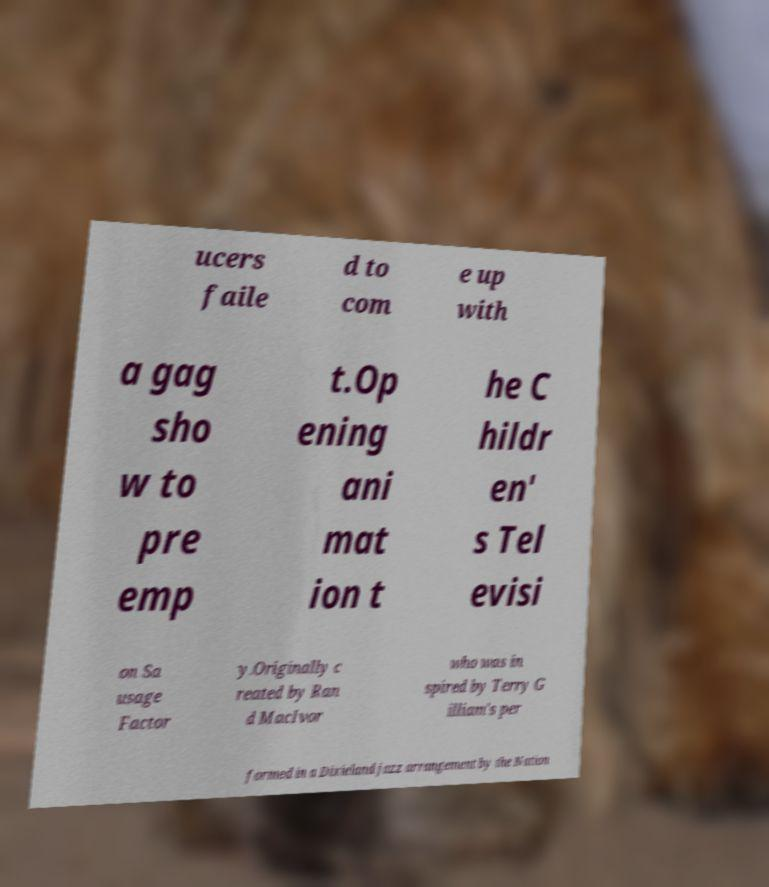Can you read and provide the text displayed in the image?This photo seems to have some interesting text. Can you extract and type it out for me? ucers faile d to com e up with a gag sho w to pre emp t.Op ening ani mat ion t he C hildr en' s Tel evisi on Sa usage Factor y.Originally c reated by Ran d MacIvor who was in spired by Terry G illiam's per formed in a Dixieland jazz arrangement by the Nation 